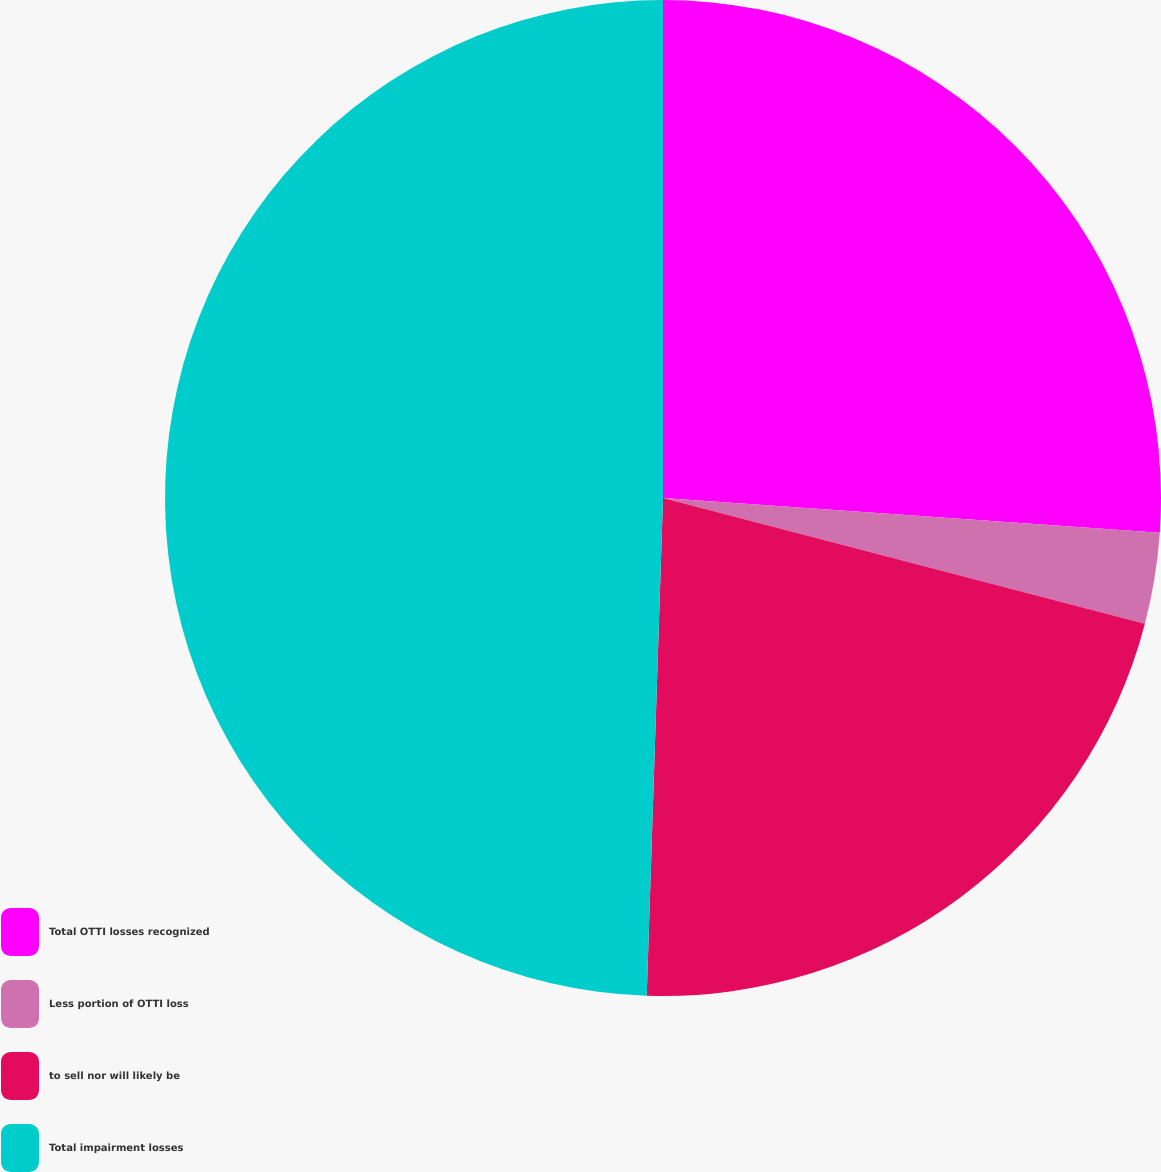Convert chart. <chart><loc_0><loc_0><loc_500><loc_500><pie_chart><fcel>Total OTTI losses recognized<fcel>Less portion of OTTI loss<fcel>to sell nor will likely be<fcel>Total impairment losses<nl><fcel>26.11%<fcel>2.95%<fcel>21.46%<fcel>49.48%<nl></chart> 